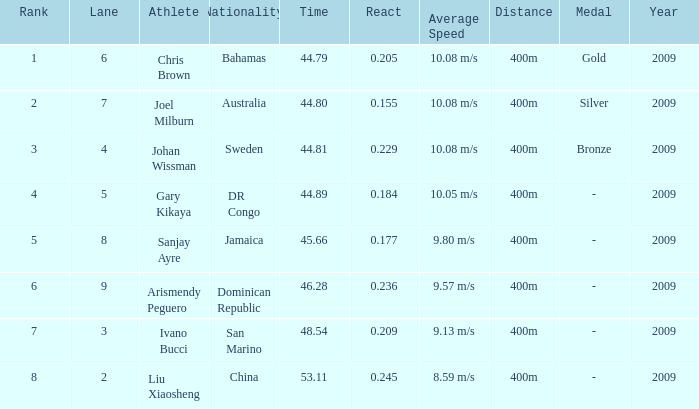What Lane has a 0.209 React entered with a Rank entry that is larger than 6? 2.0. Could you parse the entire table? {'header': ['Rank', 'Lane', 'Athlete', 'Nationality', 'Time', 'React', 'Average Speed', 'Distance', 'Medal', 'Year'], 'rows': [['1', '6', 'Chris Brown', 'Bahamas', '44.79', '0.205', '10.08 m/s', '400m', 'Gold', '2009'], ['2', '7', 'Joel Milburn', 'Australia', '44.80', '0.155', '10.08 m/s', '400m', 'Silver', '2009'], ['3', '4', 'Johan Wissman', 'Sweden', '44.81', '0.229', '10.08 m/s', '400m', 'Bronze', '2009'], ['4', '5', 'Gary Kikaya', 'DR Congo', '44.89', '0.184', '10.05 m/s', '400m', '-', '2009'], ['5', '8', 'Sanjay Ayre', 'Jamaica', '45.66', '0.177', '9.80 m/s', '400m', '-', '2009'], ['6', '9', 'Arismendy Peguero', 'Dominican Republic', '46.28', '0.236', '9.57 m/s', '400m', '-', '2009'], ['7', '3', 'Ivano Bucci', 'San Marino', '48.54', '0.209', '9.13 m/s', '400m', '-', '2009'], ['8', '2', 'Liu Xiaosheng', 'China', '53.11', '0.245', '8.59 m/s', '400m', '-', '2009']]} 